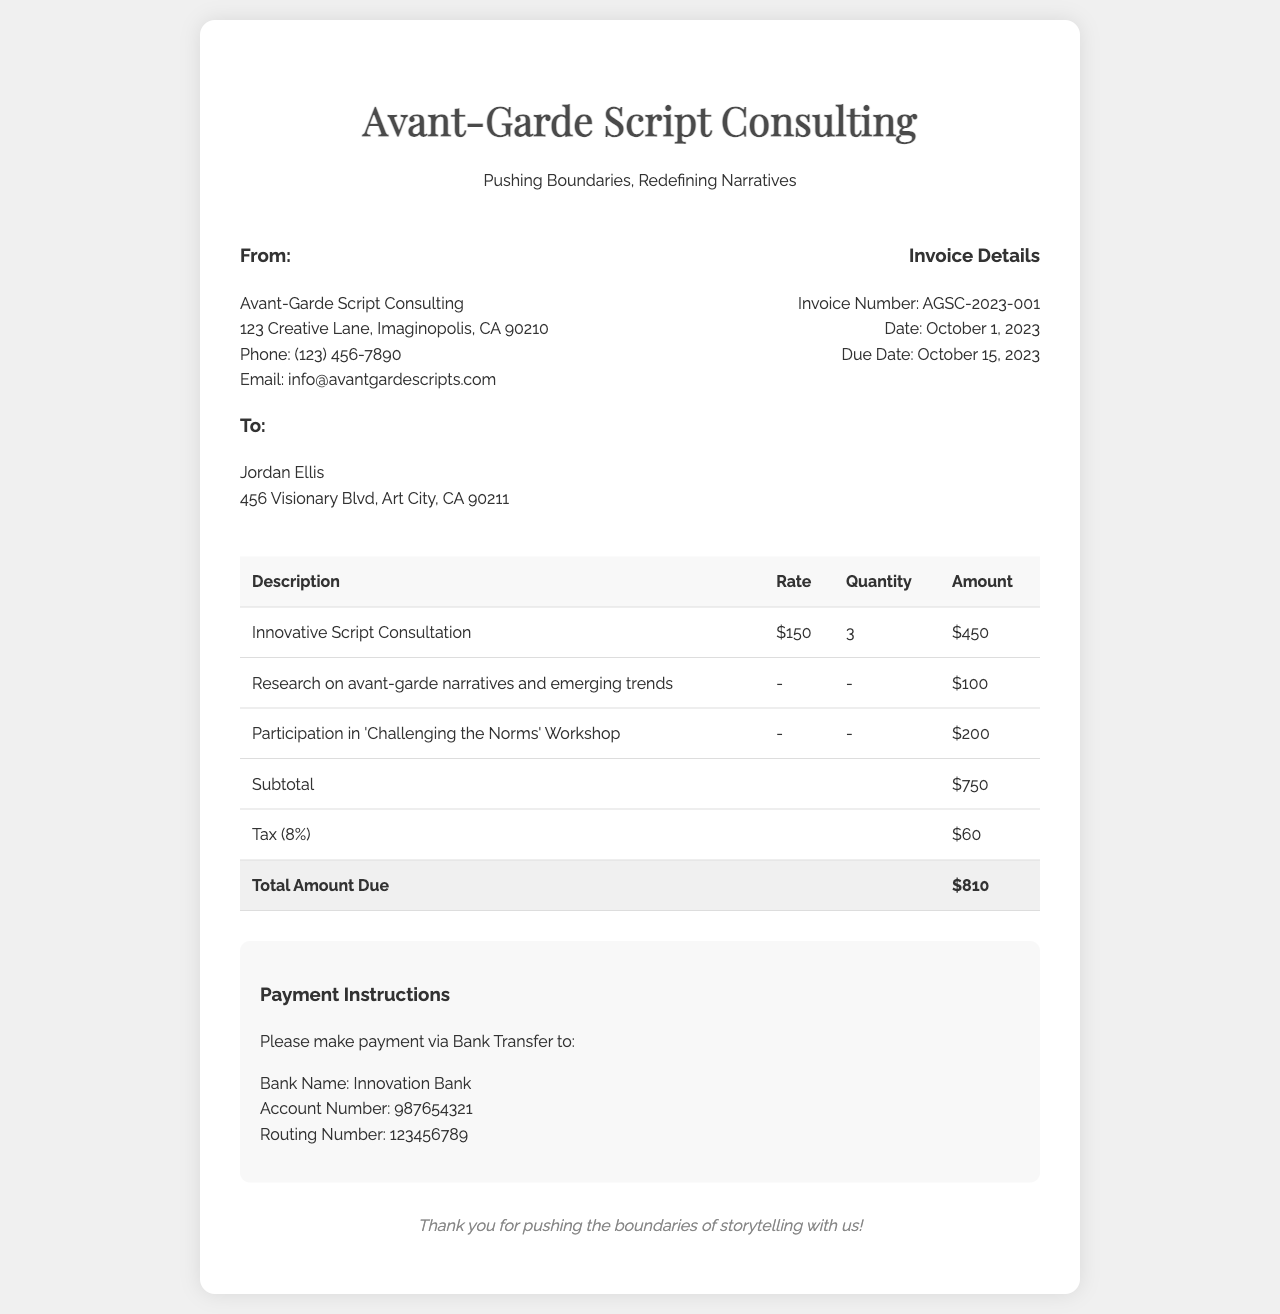What is the invoice number? The invoice number is clearly stated in the invoice details section.
Answer: AGSC-2023-001 What is the total amount due? The total amount due is calculated at the bottom of the invoice in the total row.
Answer: $810 Who is the recipient of the invoice? The recipient's name is listed under the "To:" section of the invoice.
Answer: Jordan Ellis What date is the invoice due? The due date is mentioned in the invoice details section.
Answer: October 15, 2023 How many innovative script consultation sessions were billed? The quantity of sessions can be found in the table under the corresponding service.
Answer: 3 What is the consultation rate per session? The rate for the innovative script consultation is presented alongside the quantity in the table.
Answer: $150 What is the subtotal before tax? The subtotal can be found in the table under the subtotal row.
Answer: $750 What additional service incurs a charge of $200? The service description is listed in the table, specifying the unique service provided.
Answer: Participation in 'Challenging the Norms' Workshop What is the tax percentage applied to the subtotal? The tax percentage is indicated next to the tax line in the table.
Answer: 8% 